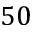Convert formula to latex. <formula><loc_0><loc_0><loc_500><loc_500>5 0</formula> 